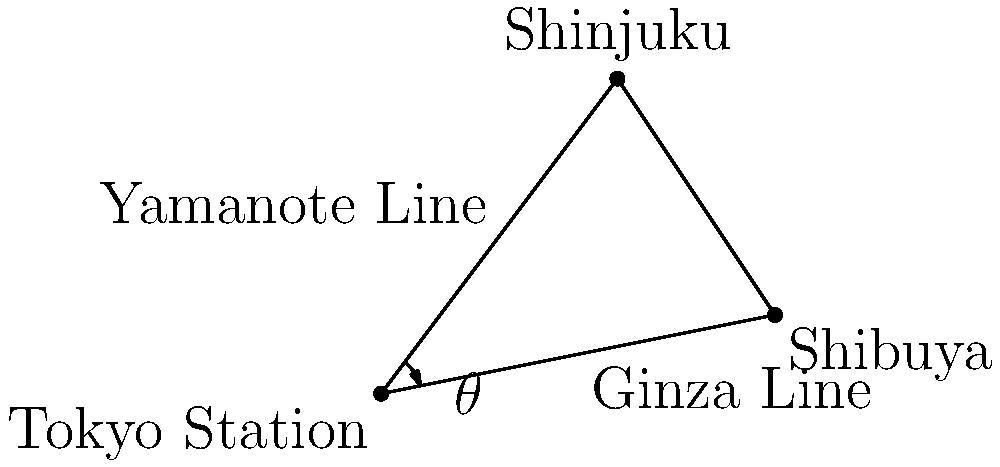On this simplified map of Tokyo's subway system, the Yamanote Line connects Tokyo Station to Shinjuku, while the Ginza Line connects Tokyo Station to Shibuya. If the angle between these two lines is represented by $\theta$, calculate the value of $\theta$ in degrees. To solve this problem, we can use the concept of vector angles. Let's approach this step-by-step:

1) First, we need to treat the subway lines as vectors from Tokyo Station (origin) to their respective destinations.

2) Let's define our vectors:
   Vector OA (Yamanote Line): From (0,0) to (3,4)
   Vector OB (Ginza Line): From (0,0) to (5,1)

3) The formula for the angle between two vectors $\vec{a}$ and $\vec{b}$ is:

   $$\cos \theta = \frac{\vec{a} \cdot \vec{b}}{|\vec{a}||\vec{b}|}$$

4) Let's calculate the dot product $\vec{a} \cdot \vec{b}$:
   $\vec{a} \cdot \vec{b} = 3(5) + 4(1) = 15 + 4 = 19$

5) Now, let's calculate the magnitudes:
   $|\vec{a}| = \sqrt{3^2 + 4^2} = 5$
   $|\vec{b}| = \sqrt{5^2 + 1^2} = \sqrt{26}$

6) Plugging these into our formula:

   $$\cos \theta = \frac{19}{5\sqrt{26}}$$

7) To get $\theta$, we need to take the inverse cosine (arccos) of both sides:

   $$\theta = \arccos(\frac{19}{5\sqrt{26}})$$

8) Using a calculator or computer, we can evaluate this:

   $$\theta \approx 0.5611 \text{ radians}$$

9) Converting to degrees:

   $$\theta \approx 0.5611 \times \frac{180}{\pi} \approx 32.14°$$
Answer: 32.14° 